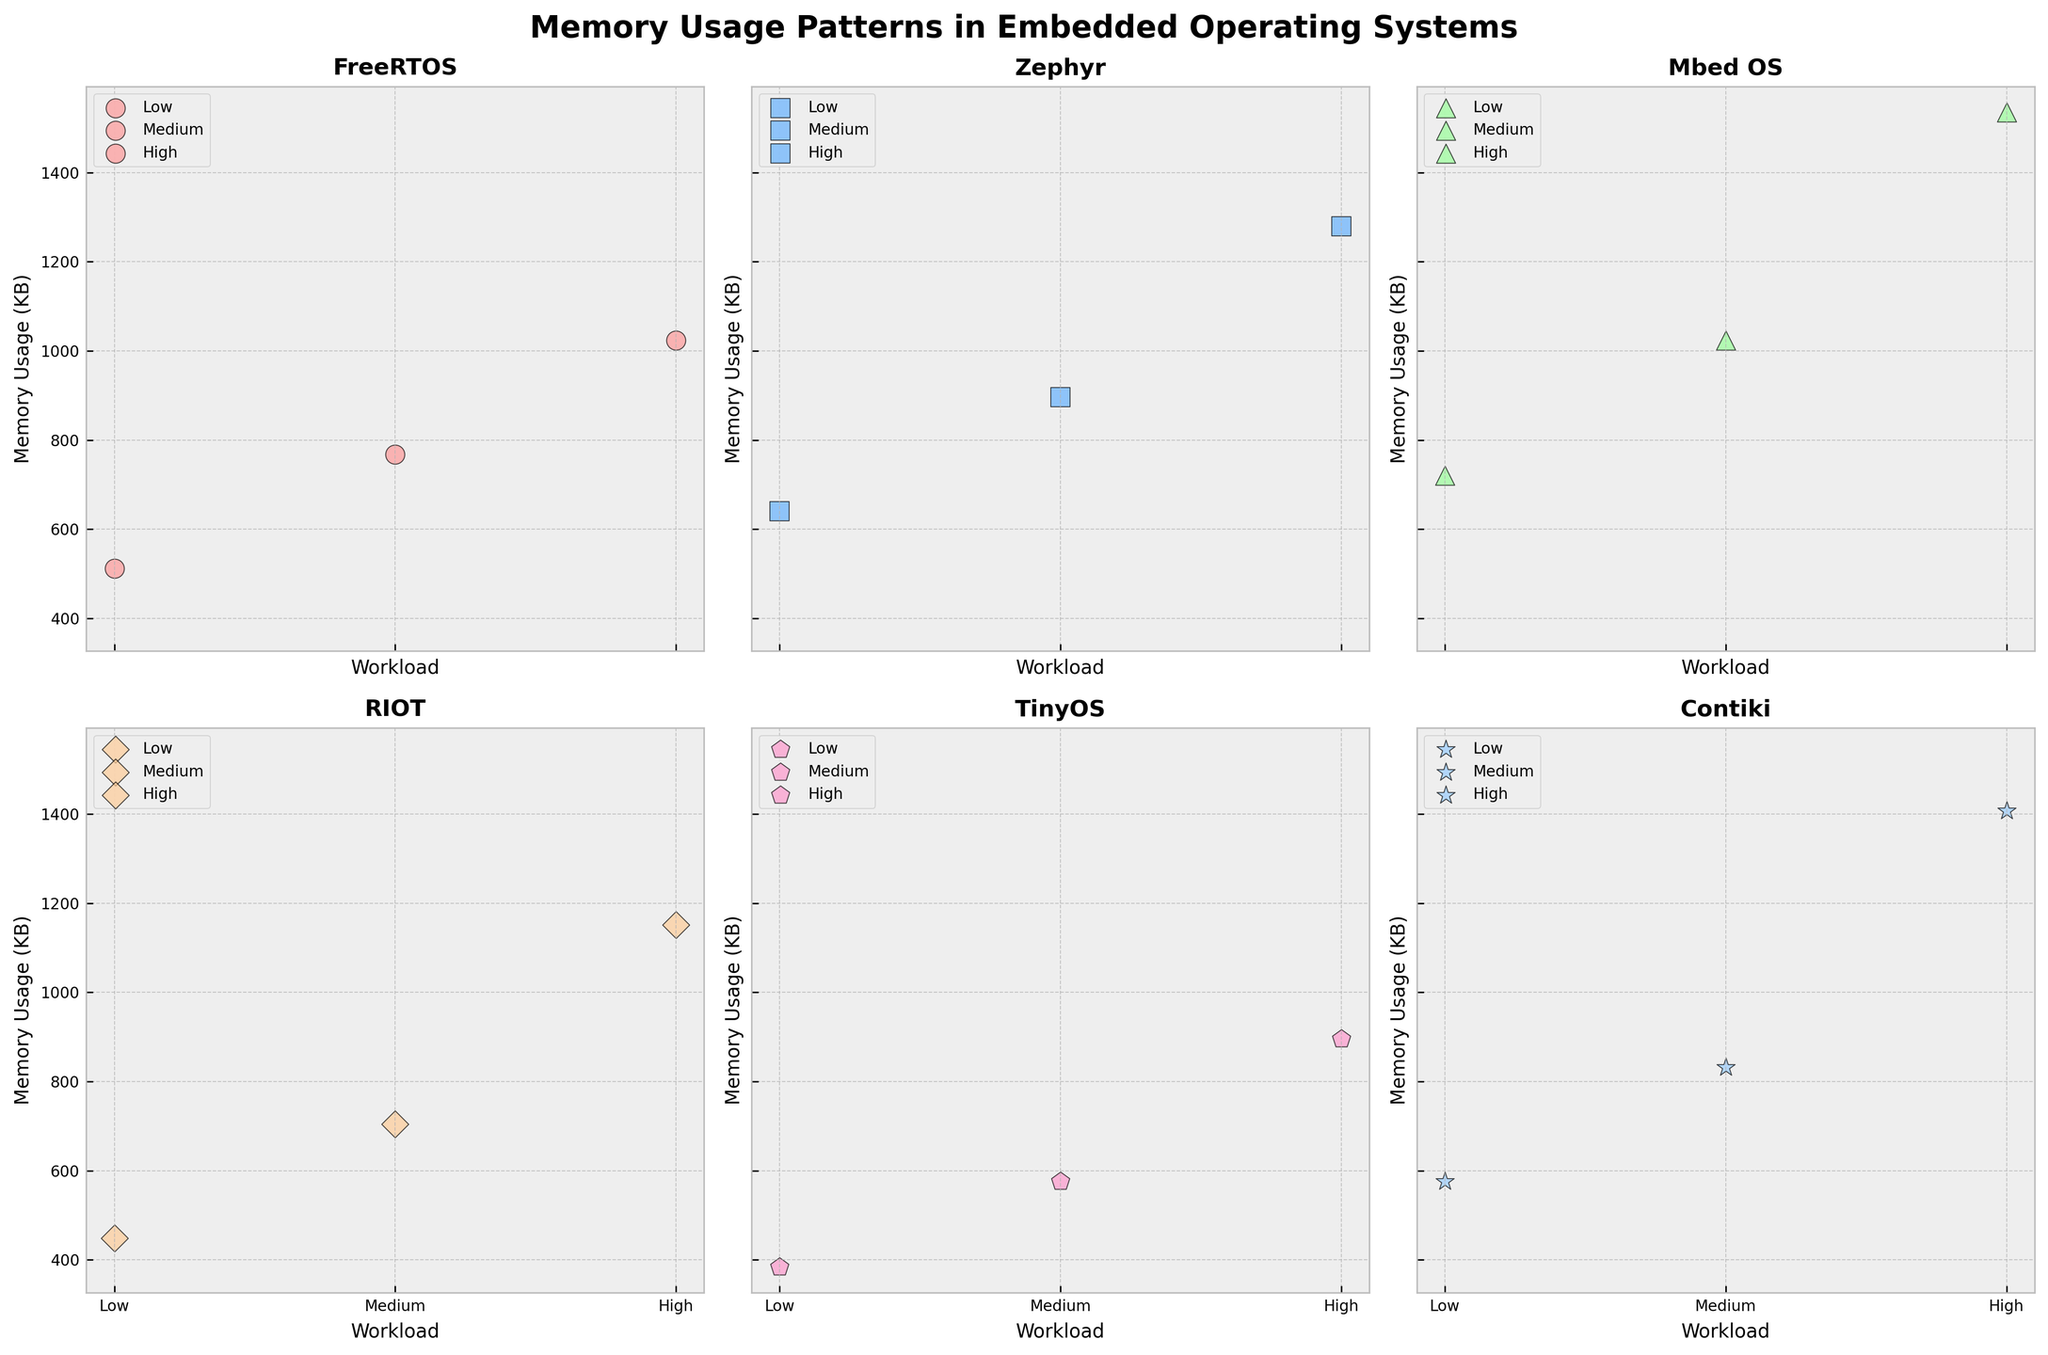What is the title of the figure? The figure's title is written at the top of the subplot. It reads "Memory Usage Patterns in Embedded Operating Systems".
Answer: Memory Usage Patterns in Embedded Operating Systems Which operating system shows the highest memory usage under high workload? Examine the 'High' workload scatter plots across all subplots. Mbed OS has the highest memory usage plot at 1536 KB.
Answer: Mbed OS How many operating systems are compared in the figure? Each subplot represents a different operating system, and there are six subplots in total.
Answer: Six Which workload level is marked by triangular markers? Triangular markers are used to represent the 'High' workload level. Look at the legend or markers in each subplot.
Answer: High What is the memory usage difference between Medium and Low workloads for Zephyr? For Zephyr, the memory usage at Medium is 896 KB and at Low is 640 KB. The difference is 896 - 640.
Answer: 256 KB Between FreeRTOS and RIOT, which OS has a lower memory usage under Medium workload? Compare the Medium workload memory usage for both. FreeRTOS has 768 KB while RIOT has 704 KB.
Answer: RIOT Is there any operating system where the memory usage under Low workload surpasses the Medium workload usage for another OS? Compare all the Low and Medium values across different subplots. Mbed OS's Low memory usage (720 KB) surpasses TinyOS's Medium memory usage (576 KB).
Answer: Yes Arrange the operating systems in ascending order based on their High workload memory usage. Look at the High workload memory usage for each OS: TinyOS (896 KB), FreeRTOS (1024 KB), RIOT (1152 KB), Zephyr (1280 KB), Contiki (1408 KB), Mbed OS (1536 KB).
Answer: TinyOS, FreeRTOS, RIOT, Zephyr, Contiki, Mbed OS Which operating system has the smallest increase in memory usage between Medium and High workloads? Calculate the difference for each OS: FreeRTOS (256 KB), Zephyr (384 KB), Mbed OS (512 KB), RIOT (448 KB), TinyOS (320 KB), Contiki (576 KB). FreeRTOS has the smallest increase.
Answer: FreeRTOS 